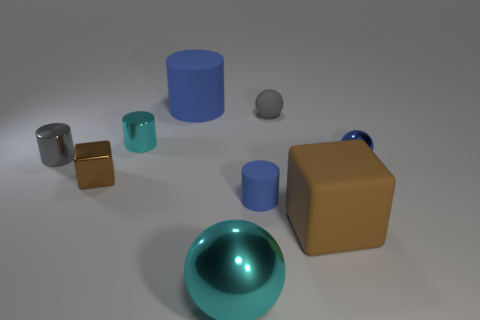Add 8 small gray cylinders. How many small gray cylinders are left? 9 Add 6 gray matte spheres. How many gray matte spheres exist? 7 Subtract all cyan cylinders. How many cylinders are left? 3 Subtract all tiny cyan cylinders. How many cylinders are left? 3 Subtract 0 purple balls. How many objects are left? 9 Subtract all spheres. How many objects are left? 6 Subtract 1 blocks. How many blocks are left? 1 Subtract all cyan blocks. Subtract all gray spheres. How many blocks are left? 2 Subtract all yellow blocks. How many green balls are left? 0 Subtract all large gray rubber things. Subtract all cyan cylinders. How many objects are left? 8 